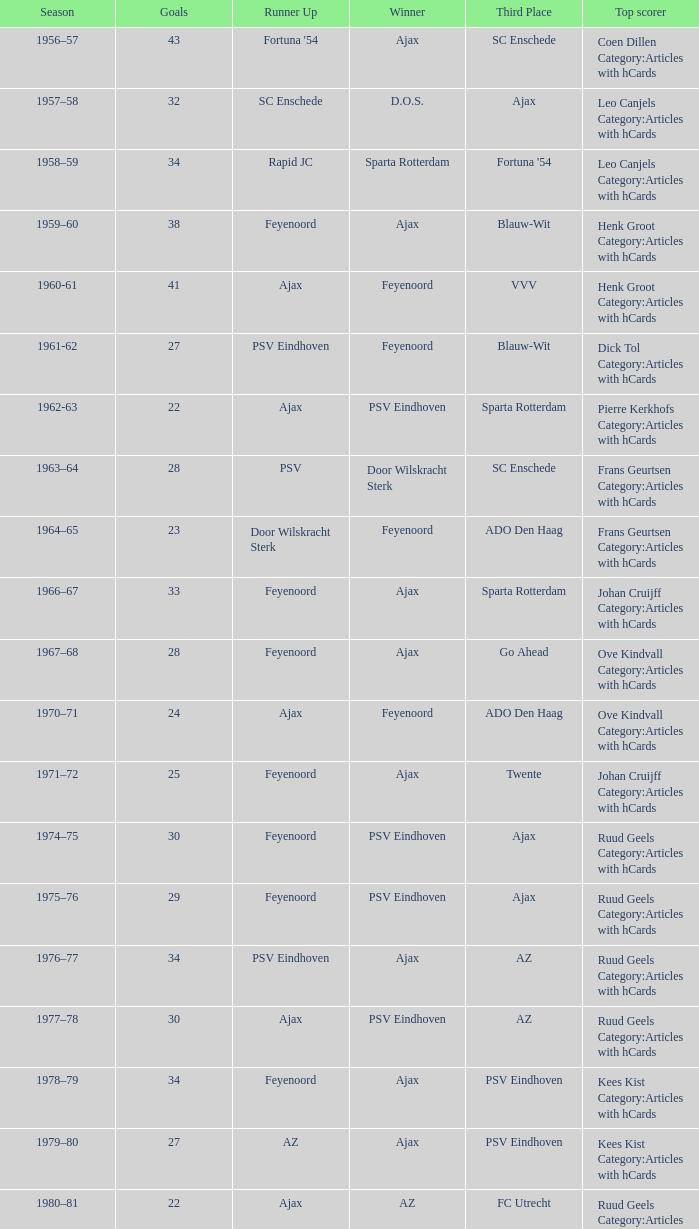When twente came in third place and ajax was the winner what are the seasons? 1971–72, 1989-90. 